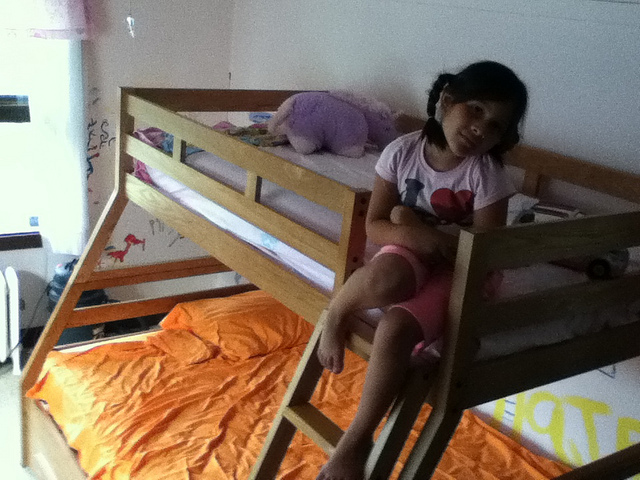Please identify all text content in this image. S I JP 